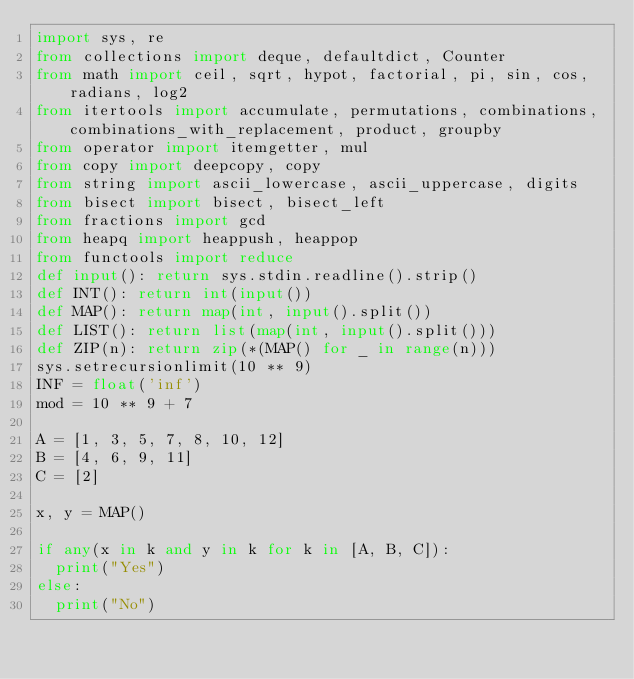<code> <loc_0><loc_0><loc_500><loc_500><_Python_>import sys, re
from collections import deque, defaultdict, Counter
from math import ceil, sqrt, hypot, factorial, pi, sin, cos, radians, log2
from itertools import accumulate, permutations, combinations, combinations_with_replacement, product, groupby
from operator import itemgetter, mul
from copy import deepcopy, copy
from string import ascii_lowercase, ascii_uppercase, digits
from bisect import bisect, bisect_left
from fractions import gcd
from heapq import heappush, heappop
from functools import reduce
def input(): return sys.stdin.readline().strip()
def INT(): return int(input())
def MAP(): return map(int, input().split())
def LIST(): return list(map(int, input().split()))
def ZIP(n): return zip(*(MAP() for _ in range(n)))
sys.setrecursionlimit(10 ** 9)
INF = float('inf')
mod = 10 ** 9 + 7

A = [1, 3, 5, 7, 8, 10, 12]
B = [4, 6, 9, 11]
C = [2]

x, y = MAP()

if any(x in k and y in k for k in [A, B, C]):
	print("Yes")
else:
	print("No")</code> 